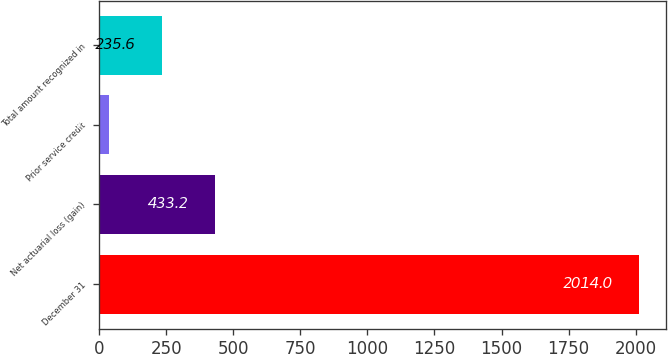<chart> <loc_0><loc_0><loc_500><loc_500><bar_chart><fcel>December 31<fcel>Net actuarial loss (gain)<fcel>Prior service credit<fcel>Total amount recognized in<nl><fcel>2014<fcel>433.2<fcel>38<fcel>235.6<nl></chart> 